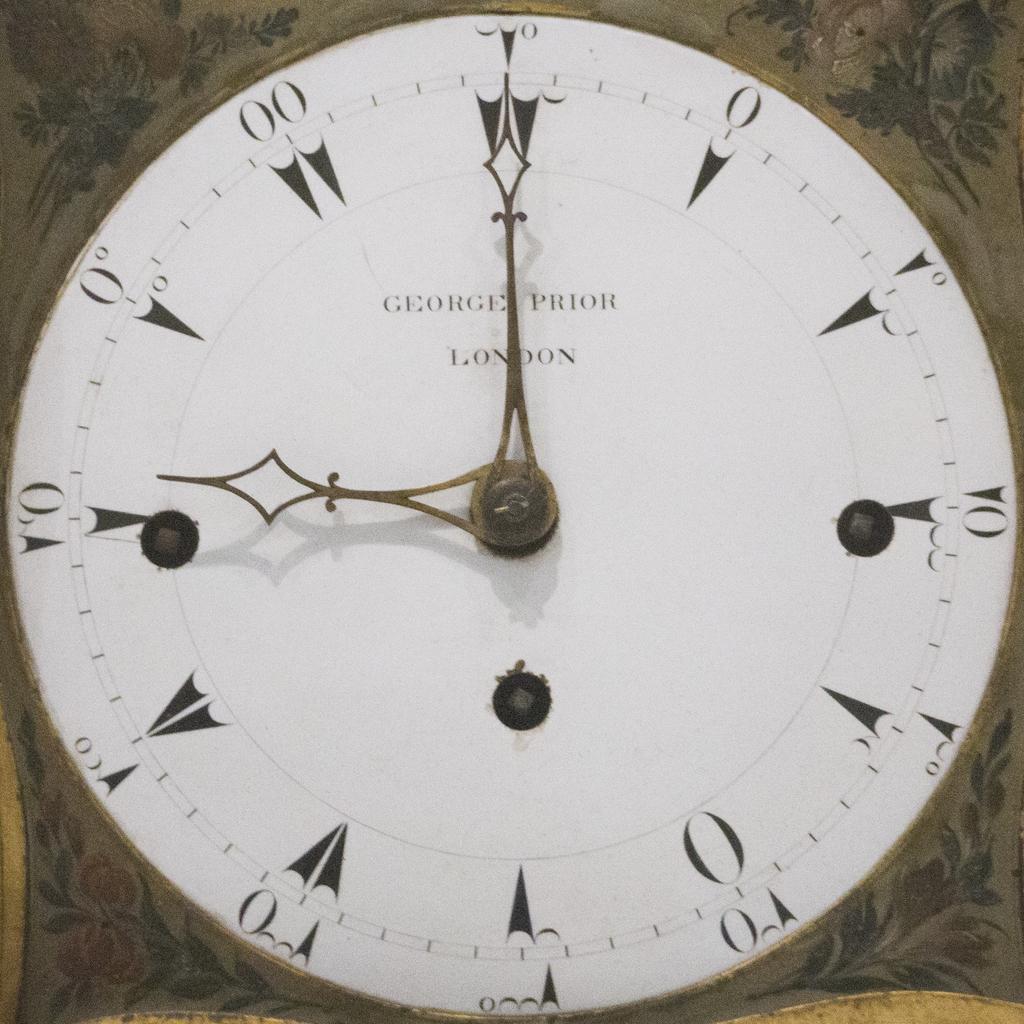Where was this clock made?
Give a very brief answer. London. What time is shown here?
Offer a terse response. 9:00. 